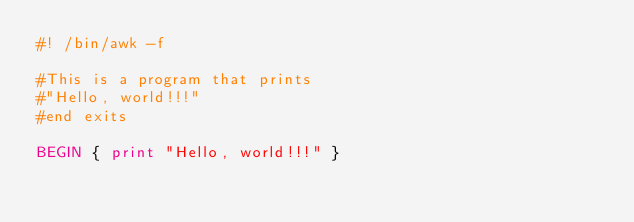<code> <loc_0><loc_0><loc_500><loc_500><_Awk_>#! /bin/awk -f

#This is a program that prints
#"Hello, world!!!"
#end exits

BEGIN { print "Hello, world!!!" } 
</code> 